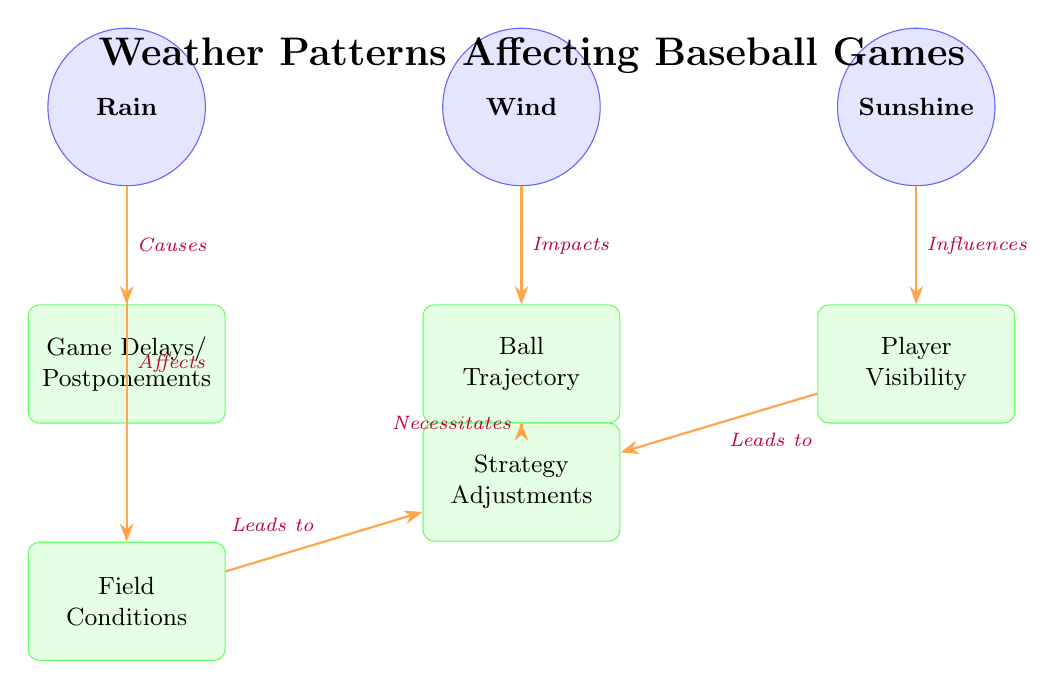What are the three weather conditions illustrated? The diagram includes the nodes for rain, wind, and sunshine as the primary weather conditions represented.
Answer: Rain, Wind, Sunshine How many effects are associated with rain? The effects associated with rain in the diagram include "Game Delays/Postponements" and "Field Conditions." This counts to a total of two effects linked to rain.
Answer: 2 What effect does wind have on the game? The diagram shows that wind impacts "Ball Trajectory," establishing a direct relationship between wind and how the ball moves during play.
Answer: Ball Trajectory How does sunshine influence the game's strategy? The sunshine directly influences "Player Visibility," which then leads to "Strategy Adjustments." This indicates that sunshine can dictate how strategies are formed based on visibility.
Answer: Player Visibility What connects both field conditions and visibility to game strategy? The diagram indicates that both "Field Conditions" and "Player Visibility" lead to "Strategy Adjustments," highlighting their joint role in shaping gameplay strategies.
Answer: Strategy Adjustments Which weather condition causes game delays? The diagram indicates that rain is the weather condition that causes "Game Delays/Postponements," making it the direct contributor to such interruptions.
Answer: Rain What is the relationship between wind and strategy adjustments? The diagram outlines that wind affects "Ball Trajectory," which necessitates associated "Strategy Adjustments," linking these concepts through their interconnected effects on the game.
Answer: Necessitates Strategy Adjustments 